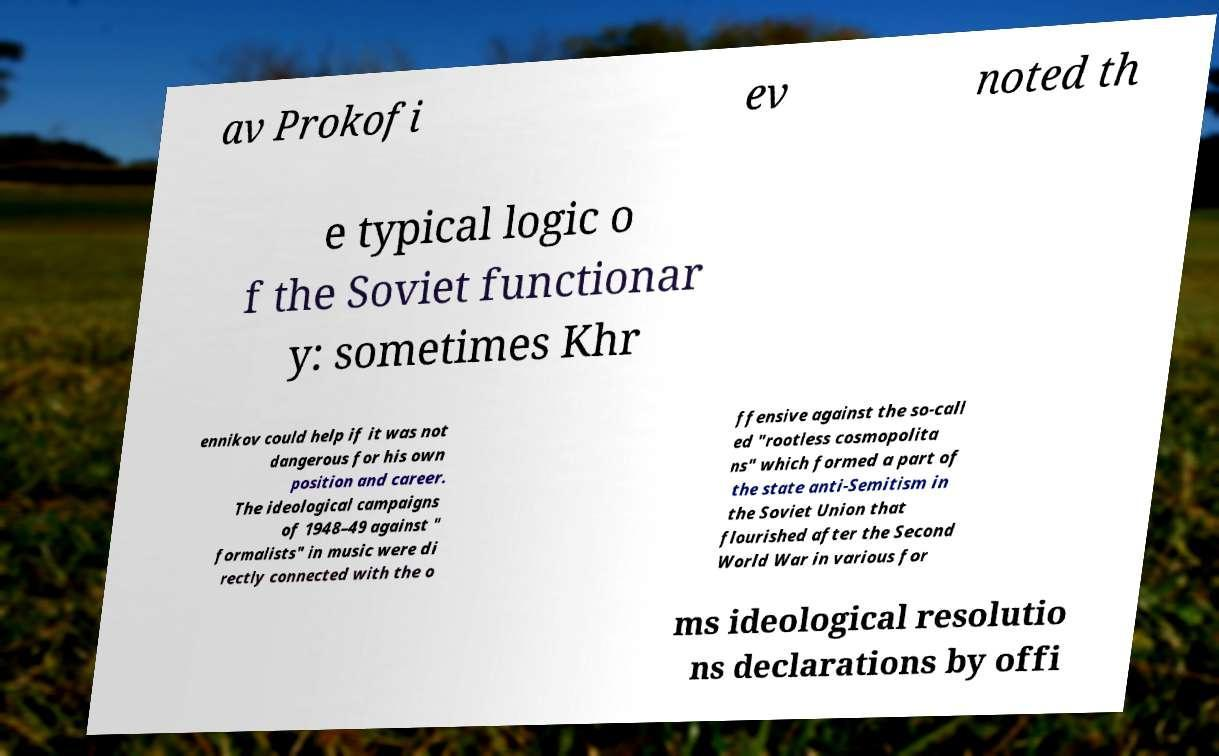Please identify and transcribe the text found in this image. av Prokofi ev noted th e typical logic o f the Soviet functionar y: sometimes Khr ennikov could help if it was not dangerous for his own position and career. The ideological campaigns of 1948–49 against " formalists" in music were di rectly connected with the o ffensive against the so-call ed "rootless cosmopolita ns" which formed a part of the state anti-Semitism in the Soviet Union that flourished after the Second World War in various for ms ideological resolutio ns declarations by offi 